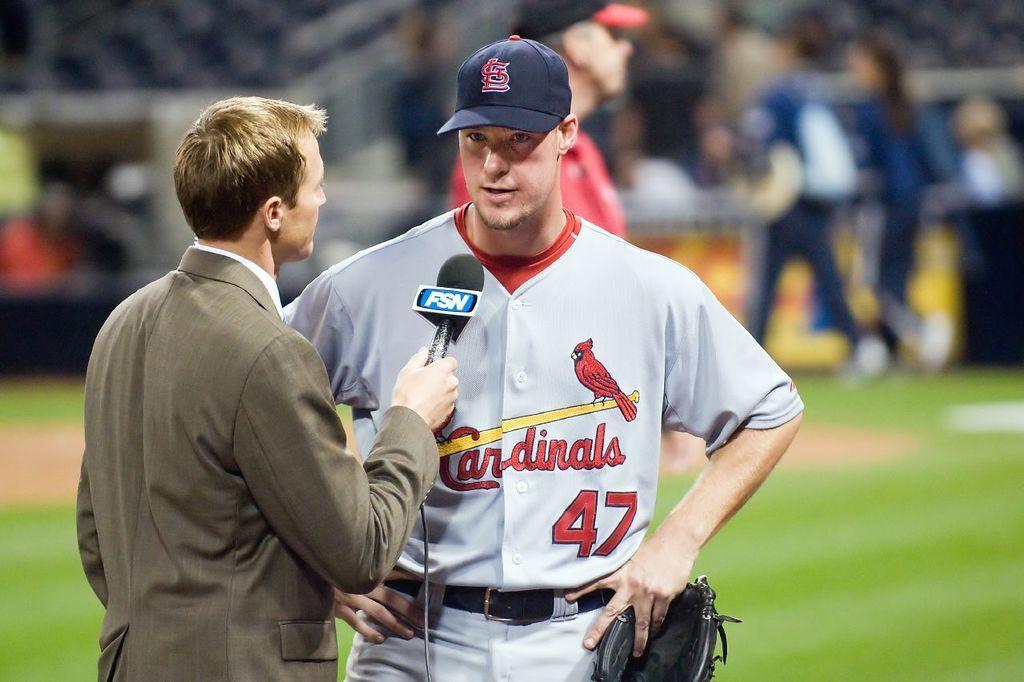Could you give a brief overview of what you see in this image? In the picture we can see a news reporter standing on the grass surface and asking some questions to the sports person who is standing, and he is with a cap and keeping his hands on his hip and holding a black color bag and behind him we can see some people are standing and they are not clearly visible. 